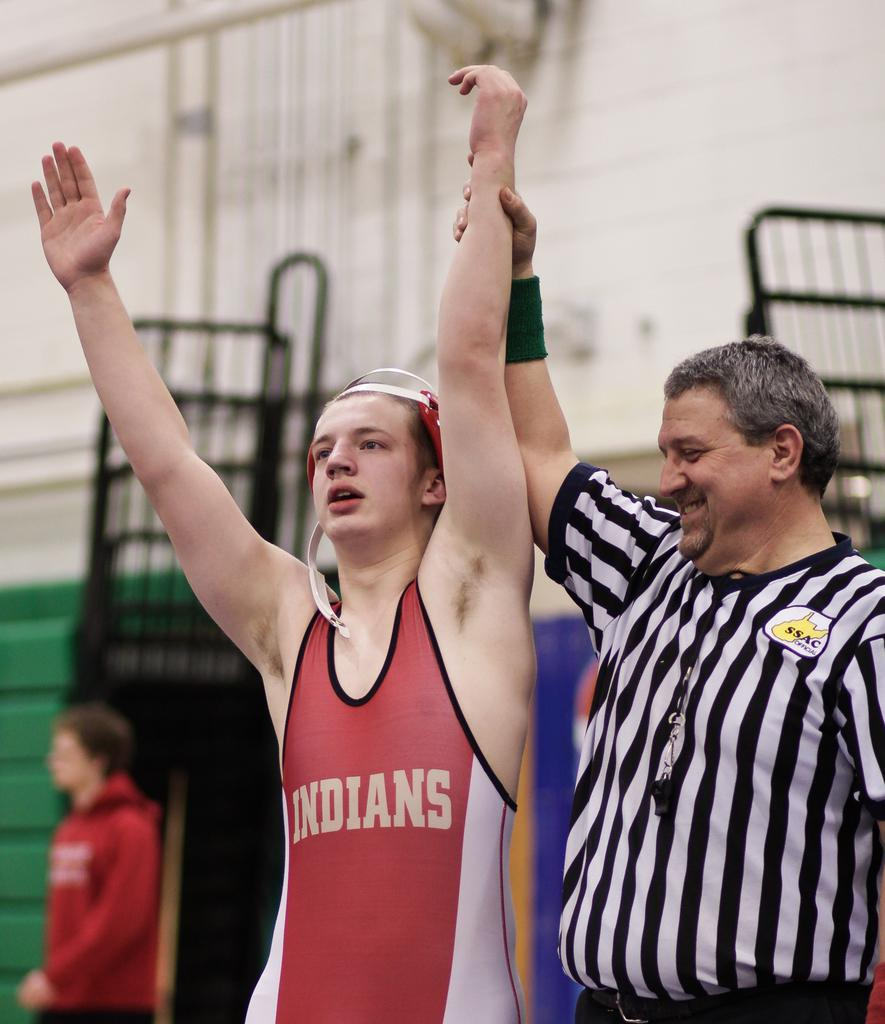<image>
Write a terse but informative summary of the picture. The winner in the red is wearing an indians top. 